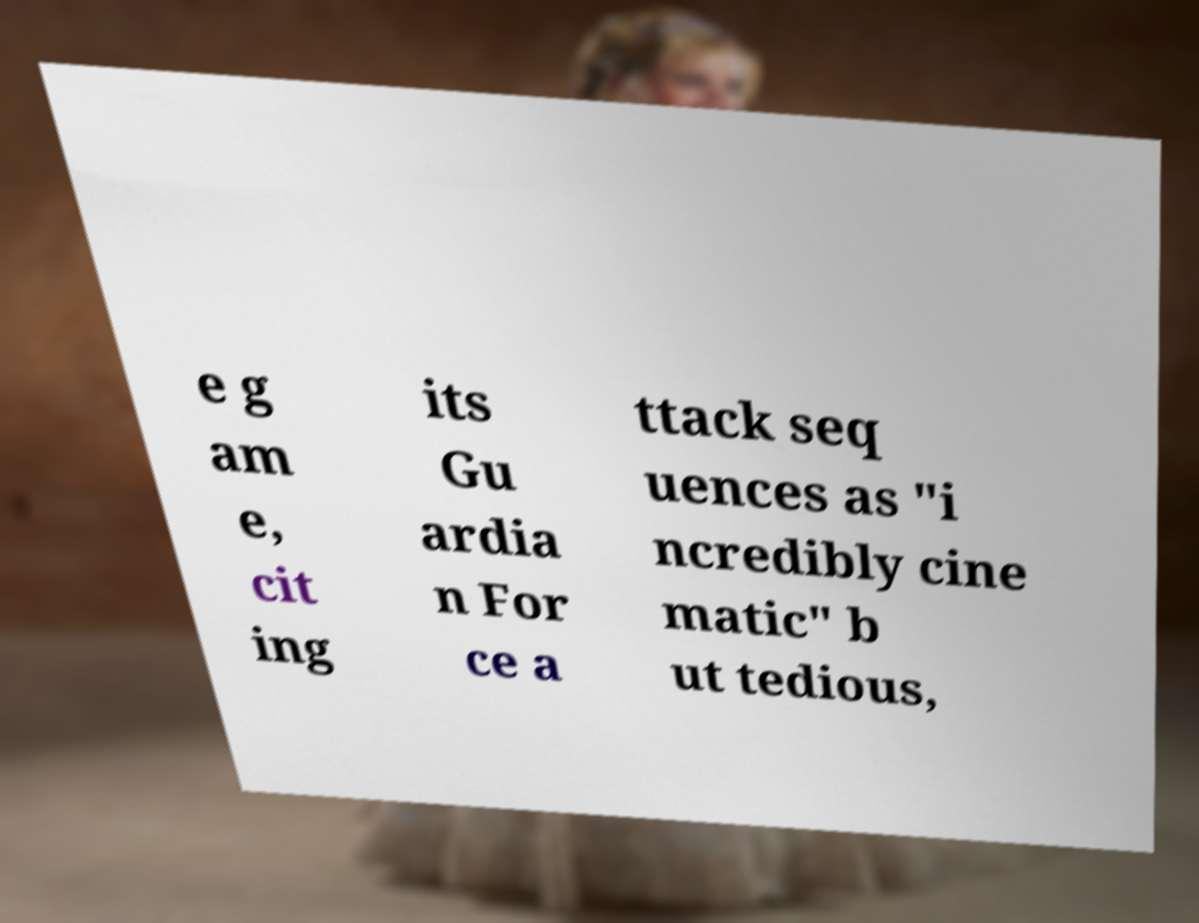I need the written content from this picture converted into text. Can you do that? e g am e, cit ing its Gu ardia n For ce a ttack seq uences as "i ncredibly cine matic" b ut tedious, 